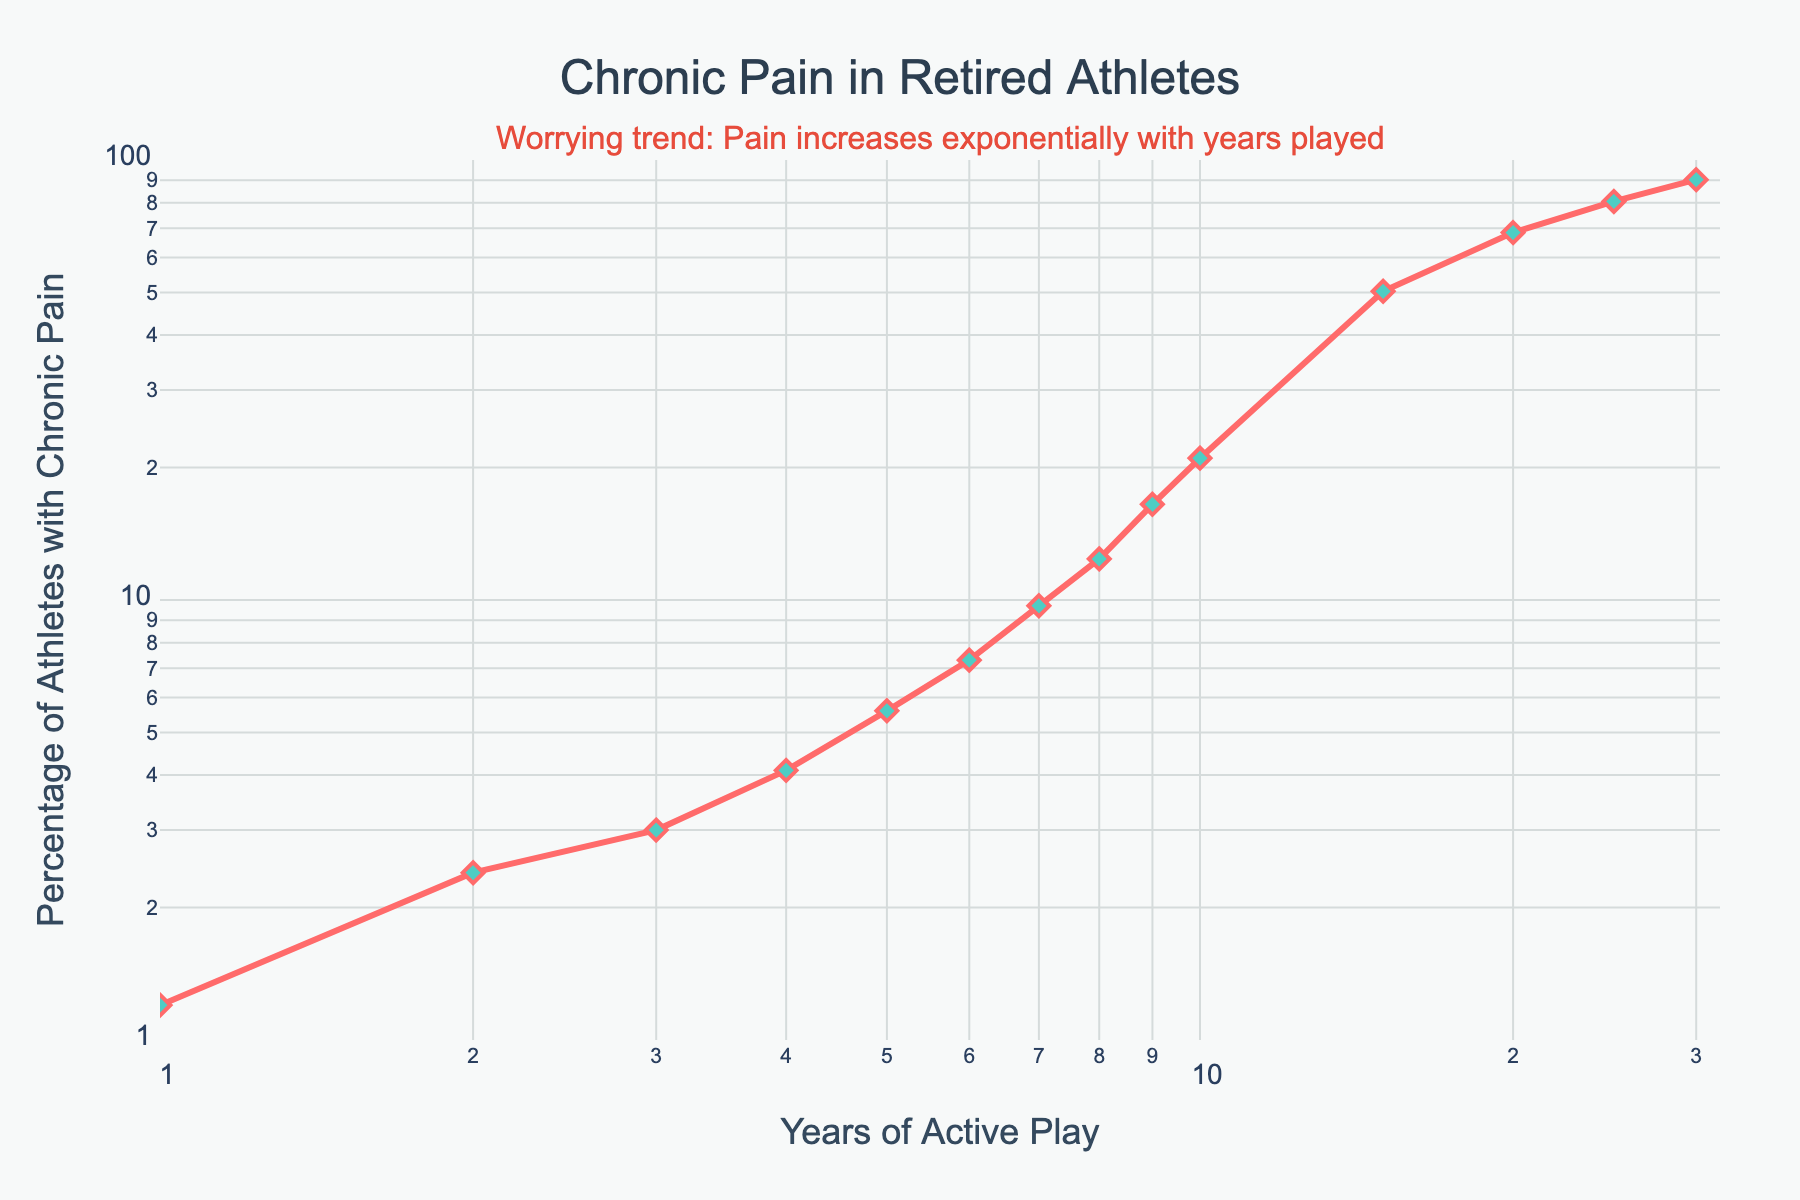How many years of active play correspond to 50.3% of retired athletes with chronic pain? To find this, look at the point where the y-axis value is 50.3%. This occurs at 15 years of active play.
Answer: 15 years When does the percentage of retired athletes with chronic pain reach approximately 20%? Check the x-axis where the line crosses the y-axis value at around 20%. This occurs at approximately 10 years of active play.
Answer: 10 years At what point does the increase in chronic pain percentage accelerate significantly? Observe the plot where the slope of the line becomes steeper. The increase accelerates significantly after 10 years of active play.
Answer: After 10 years What is the percentage of retired athletes with chronic pain after 30 years of active play? Locate the data point on the graph corresponding to 30 years of active play. The y-axis value here is 90.2%.
Answer: 90.2% Which two data points have the largest absolute increase in chronic pain percentage? To find this, identify the largest difference by comparing consecutive y-values. The biggest increase is from 21.0% at 10 years to 50.3% at 15 years.
Answer: 10 to 15 years How does the percentage of chronic pain change from 5 to 20 years of active play? The percentage increases from 5.6% at 5 years to 68.4% at 20 years. Calculate the difference: 68.4% - 5.6% = 62.8%.
Answer: 62.8% increase Is there a point where the line plot remains flat or decreases? The line plot should be examined for horizontal or declining segments. It always increases without any flat or decreasing sections.
Answer: No flat or decrease What can be inferred about the trend in chronic pain as years of active play increase? The line plot shows an exponential increase in the percentage of retired athletes with chronic pain, indicating a worsening trend as active years increase.
Answer: Exponential increase Compare the percentage of chronic pain for athletes with 8 and 25 years of play. Refer to the points for 8 years (12.4%) and 25 years (80.5%). Calculate the difference: 80.5% - 12.4% = 68.1%.
Answer: 68.1% higher at 25 years What is the pain percentage at 1 year, and how does it compare to 2 years? Find the percentages at 1 year (1.2%) and 2 years (2.4%). Calculate the difference: 2.4% - 1.2% = 1.2%.
Answer: 1.2% higher at 2 years 